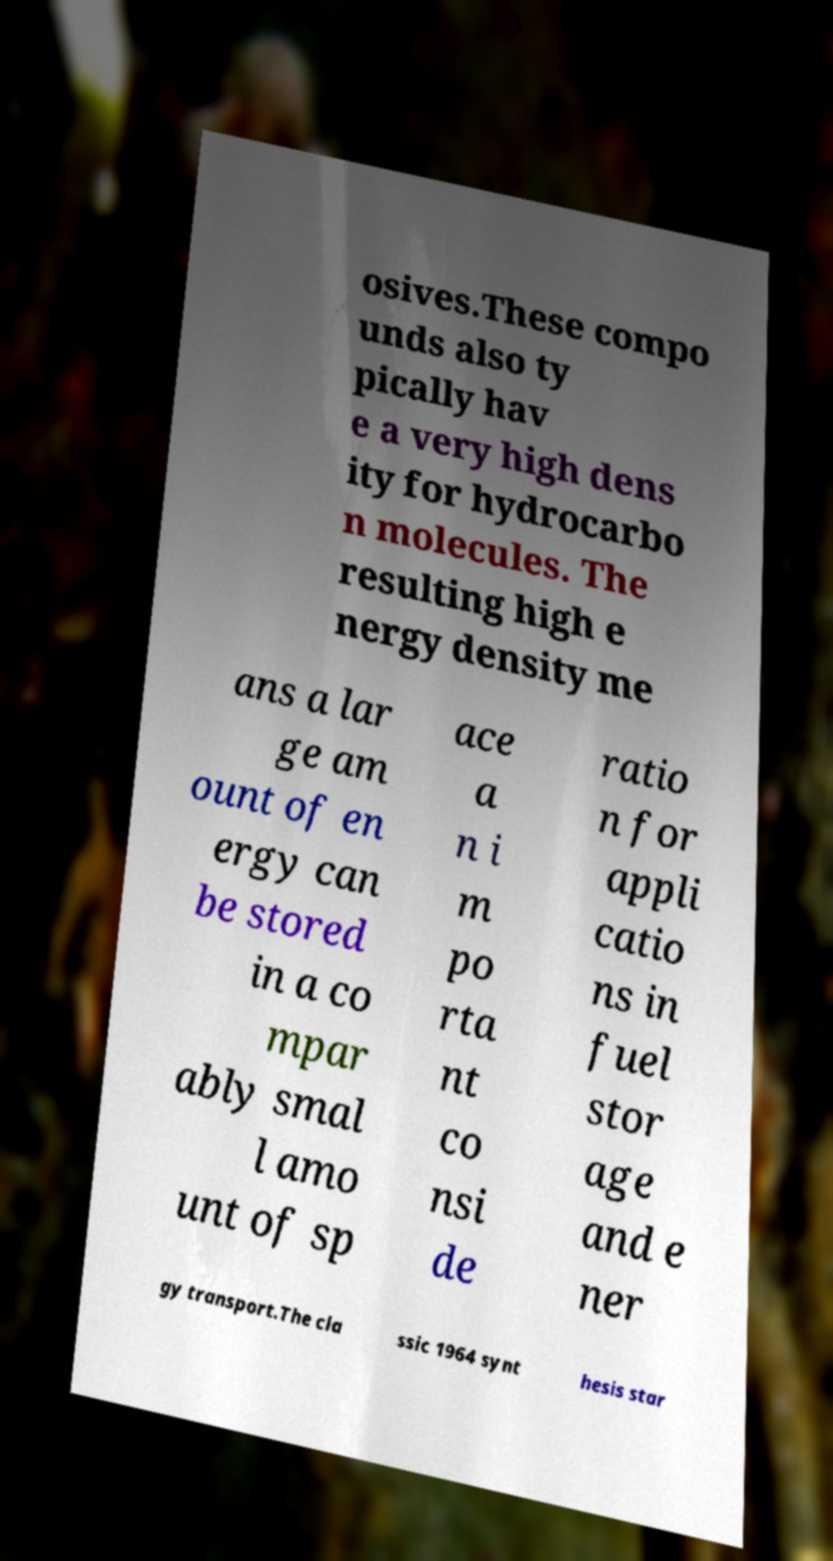Can you read and provide the text displayed in the image?This photo seems to have some interesting text. Can you extract and type it out for me? osives.These compo unds also ty pically hav e a very high dens ity for hydrocarbo n molecules. The resulting high e nergy density me ans a lar ge am ount of en ergy can be stored in a co mpar ably smal l amo unt of sp ace a n i m po rta nt co nsi de ratio n for appli catio ns in fuel stor age and e ner gy transport.The cla ssic 1964 synt hesis star 